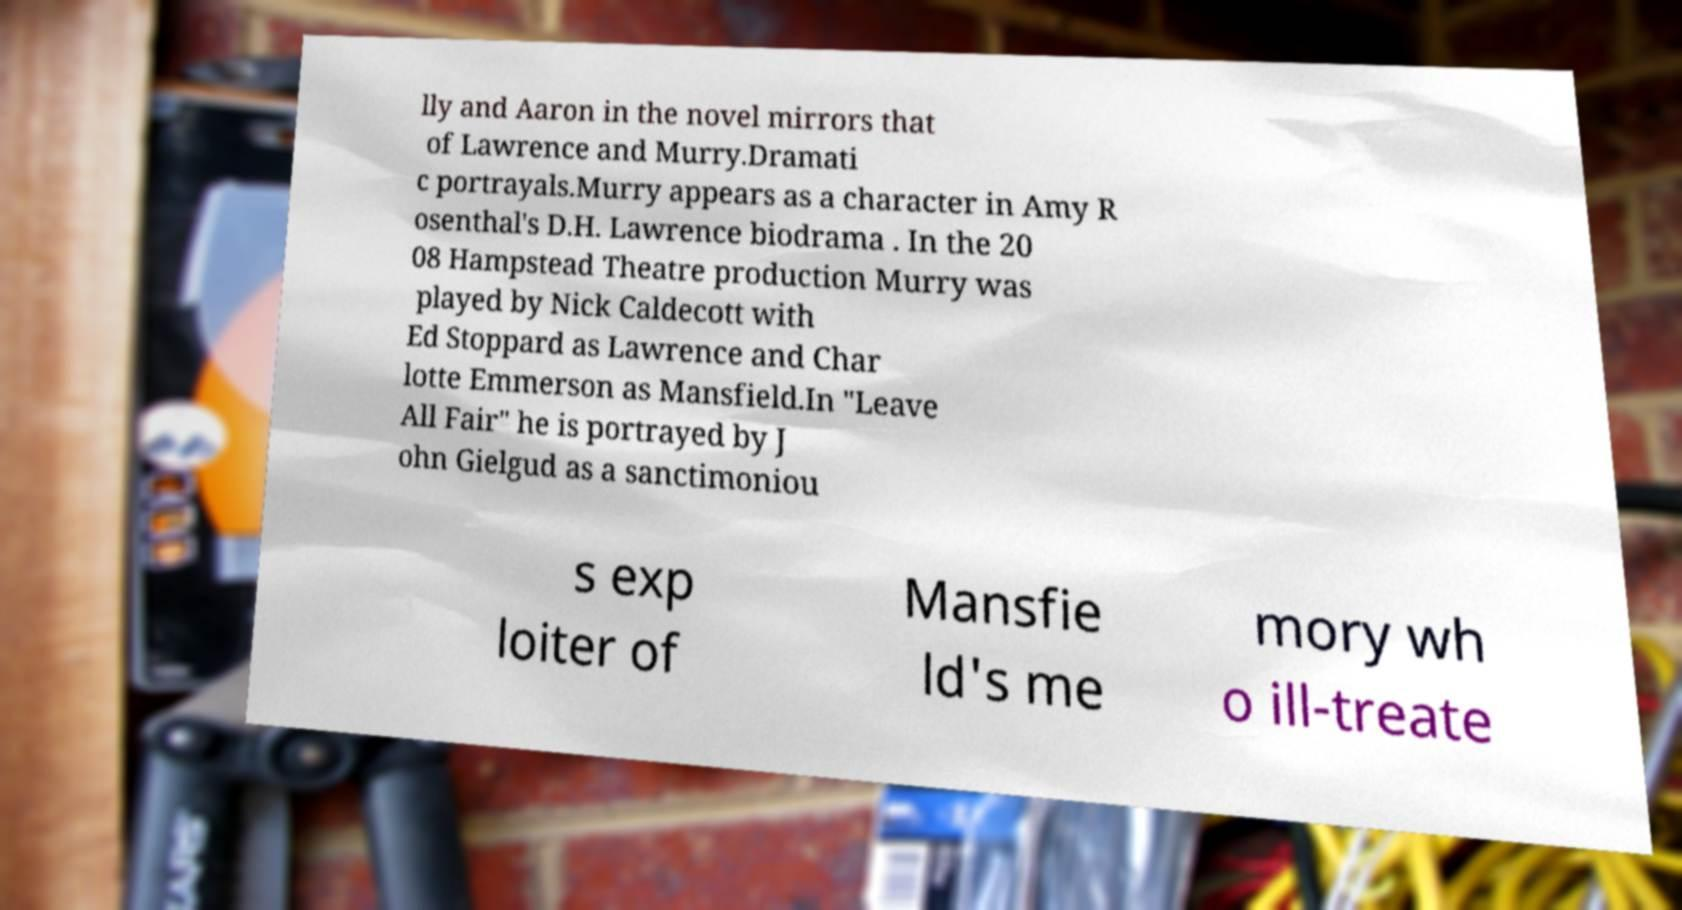Could you assist in decoding the text presented in this image and type it out clearly? lly and Aaron in the novel mirrors that of Lawrence and Murry.Dramati c portrayals.Murry appears as a character in Amy R osenthal's D.H. Lawrence biodrama . In the 20 08 Hampstead Theatre production Murry was played by Nick Caldecott with Ed Stoppard as Lawrence and Char lotte Emmerson as Mansfield.In "Leave All Fair" he is portrayed by J ohn Gielgud as a sanctimoniou s exp loiter of Mansfie ld's me mory wh o ill-treate 